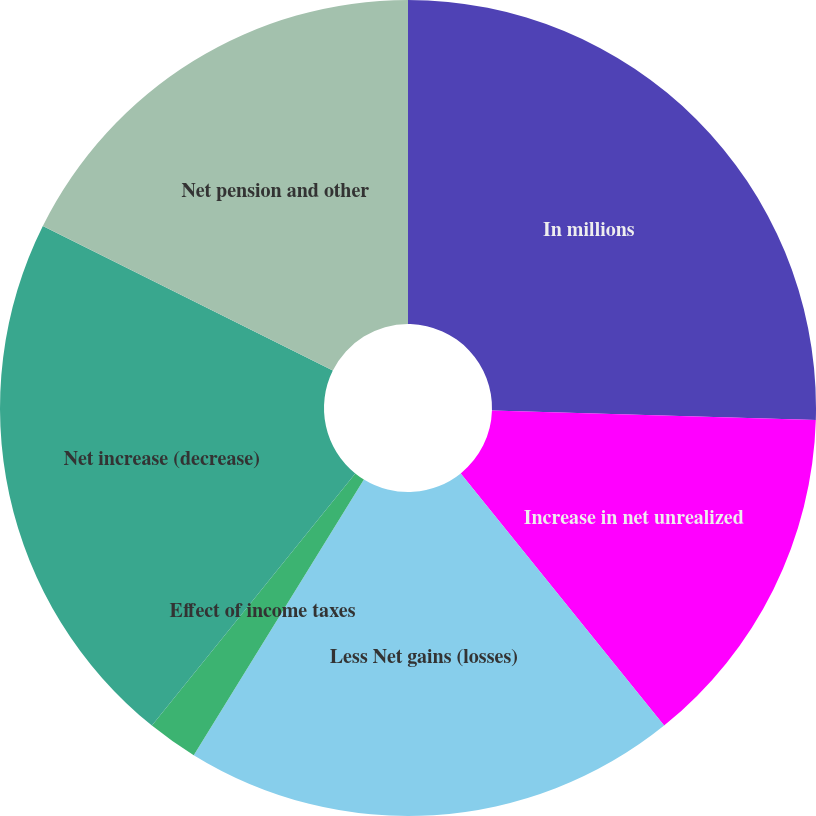<chart> <loc_0><loc_0><loc_500><loc_500><pie_chart><fcel>In millions<fcel>Increase in net unrealized<fcel>Less Net gains (losses)<fcel>Effect of income taxes<fcel>Net increase (decrease)<fcel>Net pension and other<nl><fcel>25.47%<fcel>13.73%<fcel>19.6%<fcel>2.0%<fcel>21.56%<fcel>17.64%<nl></chart> 